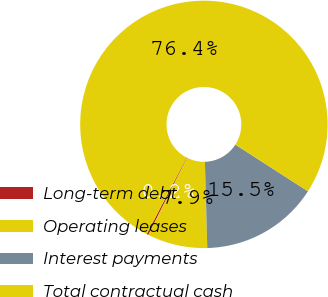Convert chart to OTSL. <chart><loc_0><loc_0><loc_500><loc_500><pie_chart><fcel>Long-term debt<fcel>Operating leases<fcel>Interest payments<fcel>Total contractual cash<nl><fcel>0.23%<fcel>7.85%<fcel>15.47%<fcel>76.44%<nl></chart> 